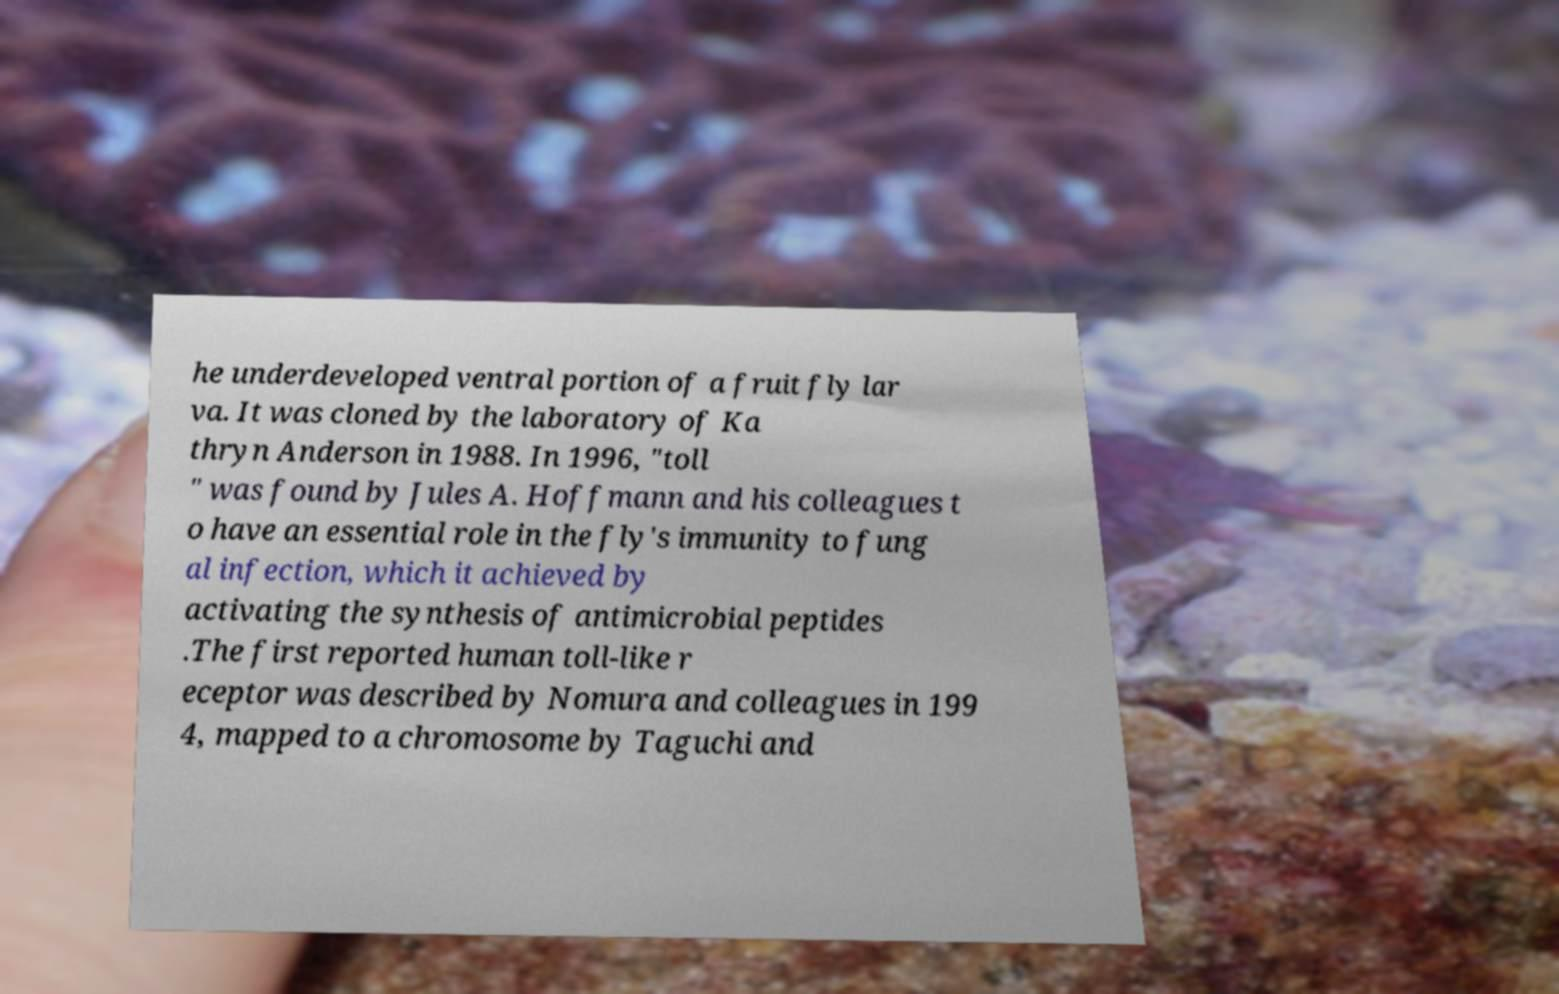Can you accurately transcribe the text from the provided image for me? he underdeveloped ventral portion of a fruit fly lar va. It was cloned by the laboratory of Ka thryn Anderson in 1988. In 1996, "toll " was found by Jules A. Hoffmann and his colleagues t o have an essential role in the fly's immunity to fung al infection, which it achieved by activating the synthesis of antimicrobial peptides .The first reported human toll-like r eceptor was described by Nomura and colleagues in 199 4, mapped to a chromosome by Taguchi and 